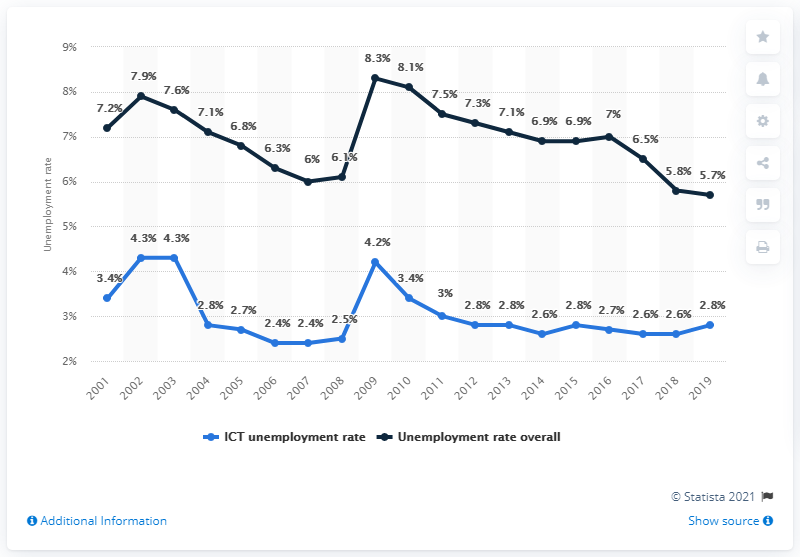Mention a couple of crucial points in this snapshot. The peak in the overall unemployment rate occurred in 2009. In 2019, the unemployment rate in Canada's Information and Communications Technology (ICT) sector was lower by 3 percentage points compared to the previous year. In 2019, the unemployment rate for Canada's Information and Communications Technology (ICT) sector was 2.8%. In 2009, the average unemployment rate for the ICT sector and the overall economy combined was 6.25%. 